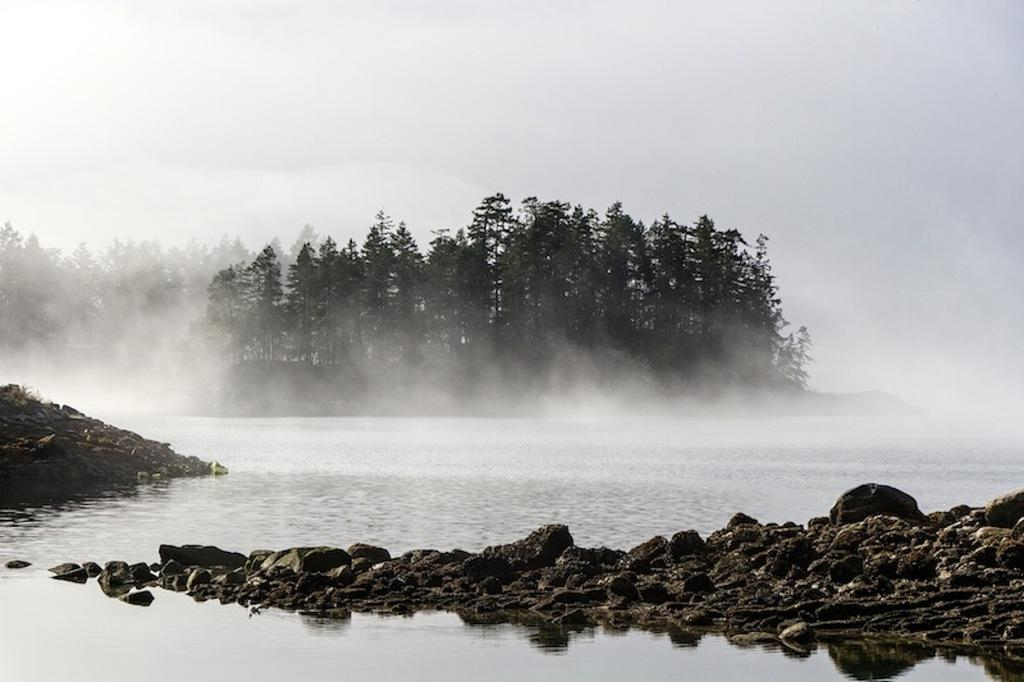What is at the bottom of the image? There is water at the bottom of the image. What type of terrain is visible in the image? Soil and rocks are present in the image. What can be seen in the background of the image? There are trees in the background of the image. What is the weather condition in the image? Fog is visible in the image. What is visible at the top of the image? The sky is visible at the top of the image. How much poison is present in the image? There is no poison present in the image. What type of hope can be seen in the image? There is no hope depicted in the image; it features natural elements such as water, soil, rocks, trees, fog, and sky. 